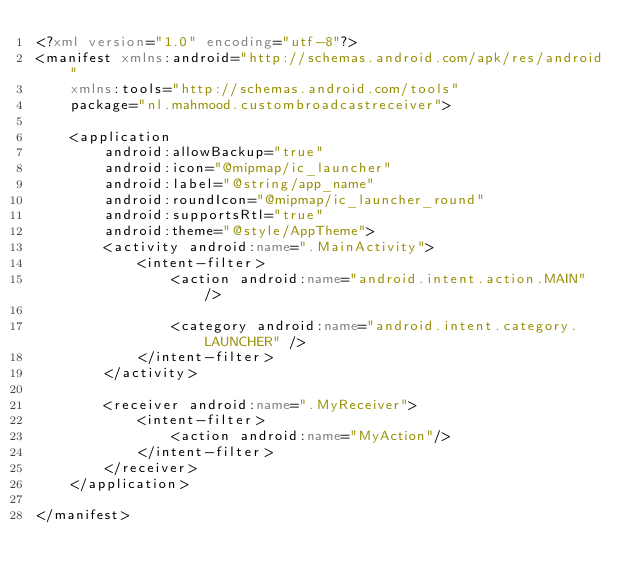Convert code to text. <code><loc_0><loc_0><loc_500><loc_500><_XML_><?xml version="1.0" encoding="utf-8"?>
<manifest xmlns:android="http://schemas.android.com/apk/res/android"
    xmlns:tools="http://schemas.android.com/tools"
    package="nl.mahmood.custombroadcastreceiver">

    <application
        android:allowBackup="true"
        android:icon="@mipmap/ic_launcher"
        android:label="@string/app_name"
        android:roundIcon="@mipmap/ic_launcher_round"
        android:supportsRtl="true"
        android:theme="@style/AppTheme">
        <activity android:name=".MainActivity">
            <intent-filter>
                <action android:name="android.intent.action.MAIN" />

                <category android:name="android.intent.category.LAUNCHER" />
            </intent-filter>
        </activity>

        <receiver android:name=".MyReceiver">
            <intent-filter>
                <action android:name="MyAction"/>
            </intent-filter>
        </receiver>
    </application>

</manifest></code> 